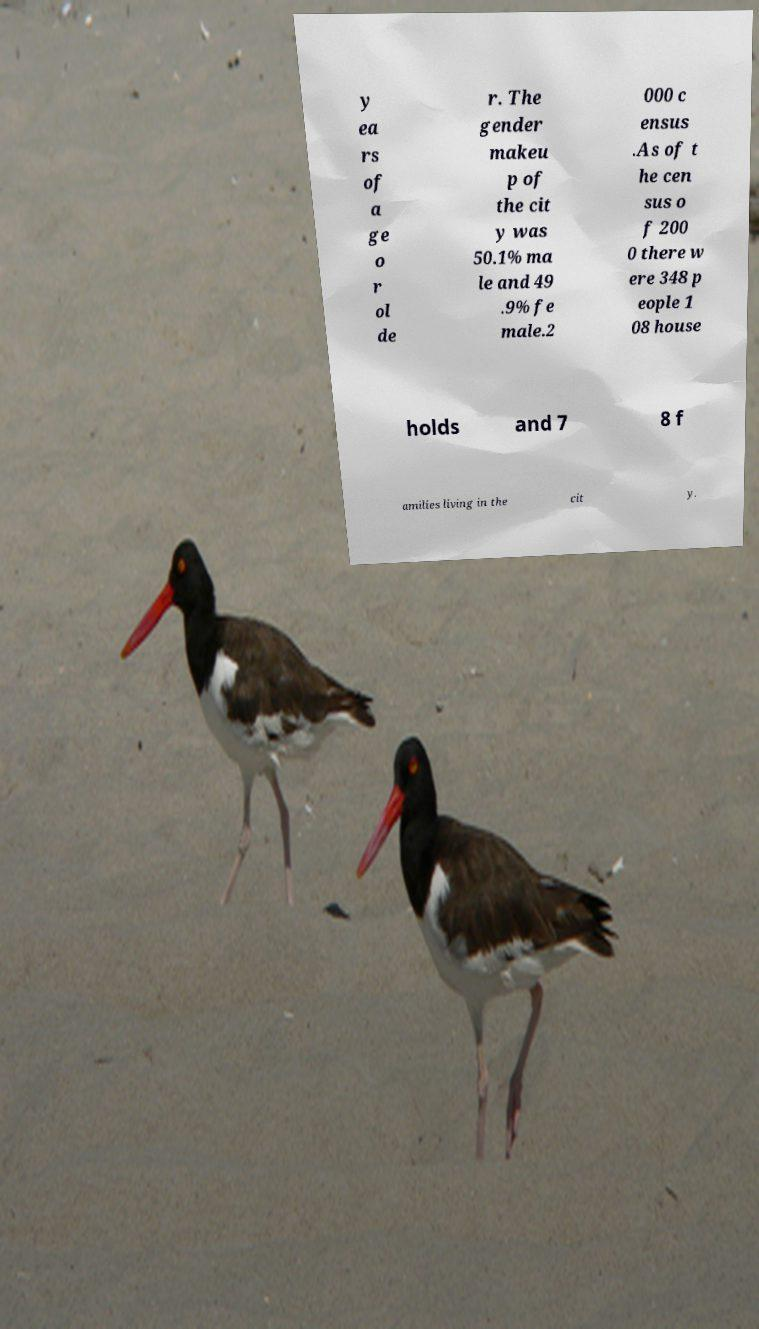For documentation purposes, I need the text within this image transcribed. Could you provide that? y ea rs of a ge o r ol de r. The gender makeu p of the cit y was 50.1% ma le and 49 .9% fe male.2 000 c ensus .As of t he cen sus o f 200 0 there w ere 348 p eople 1 08 house holds and 7 8 f amilies living in the cit y. 